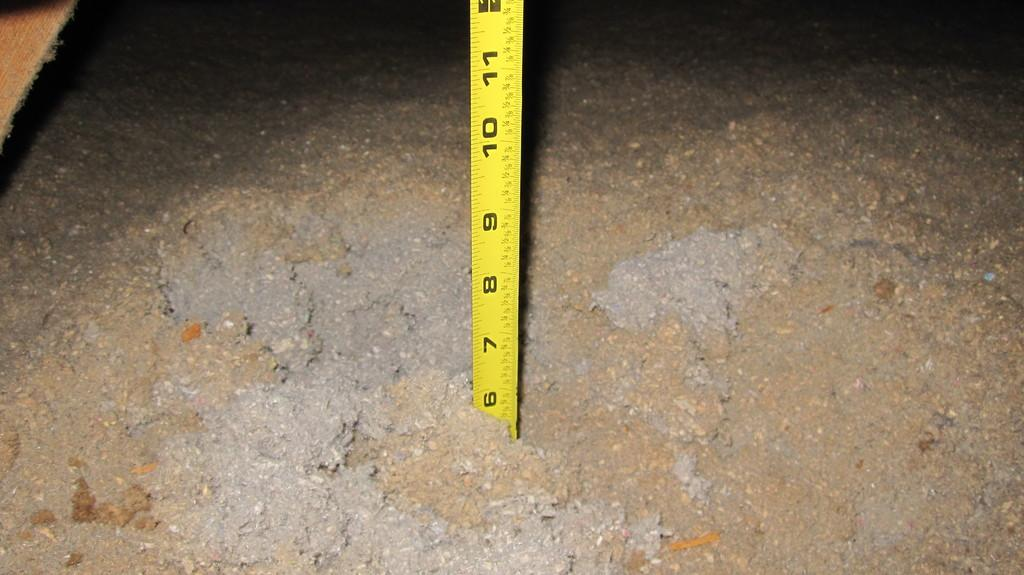<image>
Relay a brief, clear account of the picture shown. A yellow ruler that measures in inches is standing upright on a concrete surface. 